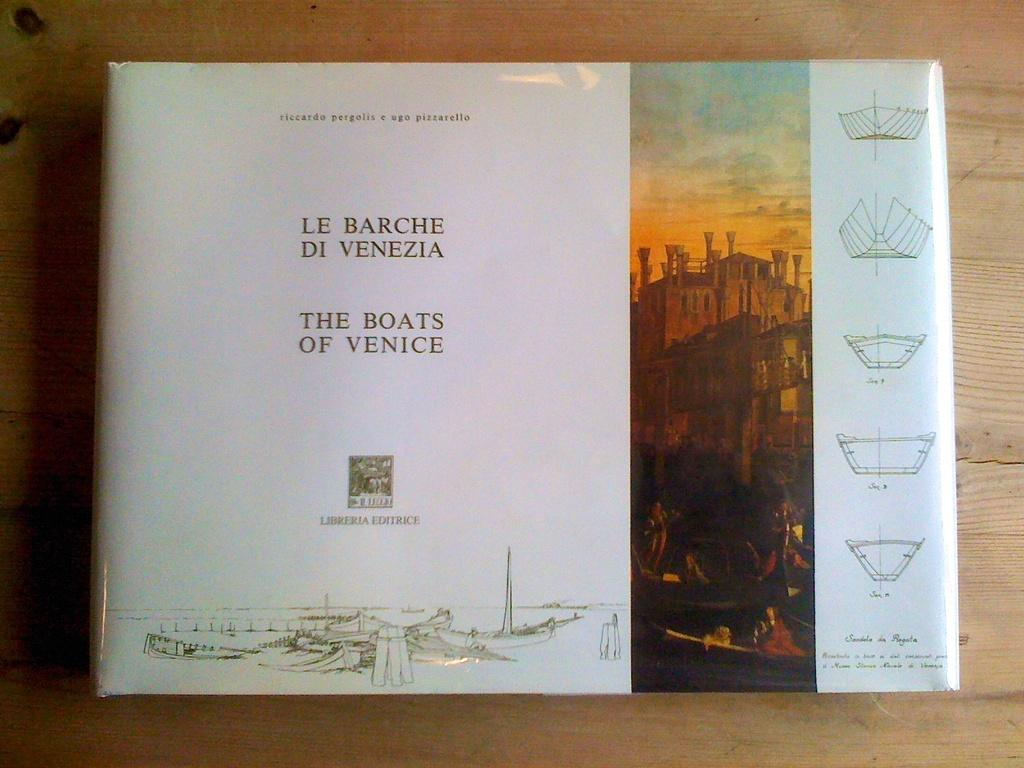Provide a one-sentence caption for the provided image. A coffee table book featuring boats of Venice, with both English and Italian writing. 